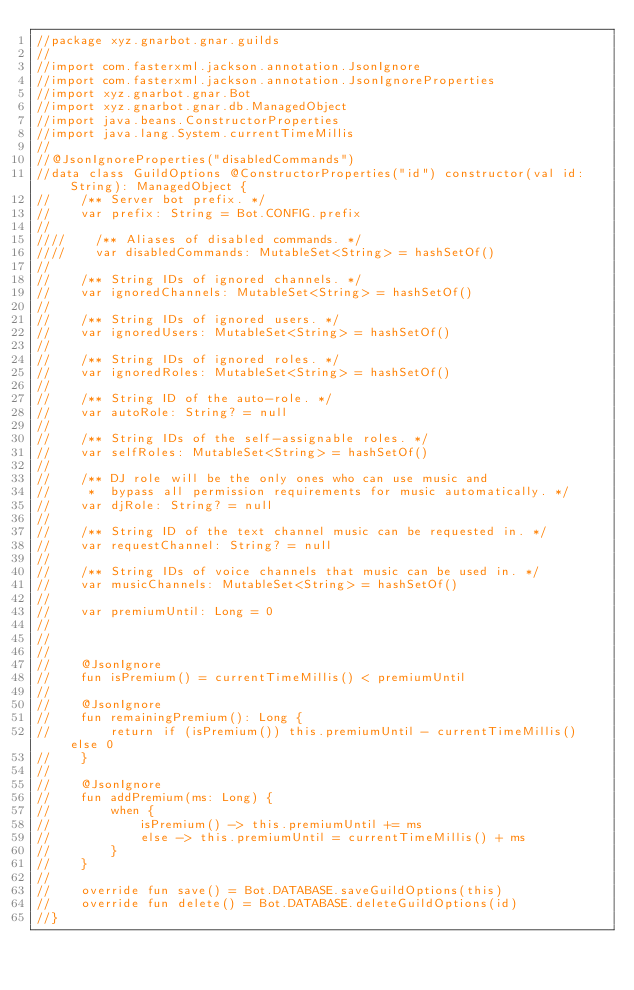Convert code to text. <code><loc_0><loc_0><loc_500><loc_500><_Kotlin_>//package xyz.gnarbot.gnar.guilds
//
//import com.fasterxml.jackson.annotation.JsonIgnore
//import com.fasterxml.jackson.annotation.JsonIgnoreProperties
//import xyz.gnarbot.gnar.Bot
//import xyz.gnarbot.gnar.db.ManagedObject
//import java.beans.ConstructorProperties
//import java.lang.System.currentTimeMillis
//
//@JsonIgnoreProperties("disabledCommands")
//data class GuildOptions @ConstructorProperties("id") constructor(val id: String): ManagedObject {
//    /** Server bot prefix. */
//    var prefix: String = Bot.CONFIG.prefix
//
////    /** Aliases of disabled commands. */
////    var disabledCommands: MutableSet<String> = hashSetOf()
//
//    /** String IDs of ignored channels. */
//    var ignoredChannels: MutableSet<String> = hashSetOf()
//
//    /** String IDs of ignored users. */
//    var ignoredUsers: MutableSet<String> = hashSetOf()
//
//    /** String IDs of ignored roles. */
//    var ignoredRoles: MutableSet<String> = hashSetOf()
//
//    /** String ID of the auto-role. */
//    var autoRole: String? = null
//
//    /** String IDs of the self-assignable roles. */
//    var selfRoles: MutableSet<String> = hashSetOf()
//
//    /** DJ role will be the only ones who can use music and
//     *  bypass all permission requirements for music automatically. */
//    var djRole: String? = null
//
//    /** String ID of the text channel music can be requested in. */
//    var requestChannel: String? = null
//
//    /** String IDs of voice channels that music can be used in. */
//    var musicChannels: MutableSet<String> = hashSetOf()
//
//    var premiumUntil: Long = 0
//
//
//
//    @JsonIgnore
//    fun isPremium() = currentTimeMillis() < premiumUntil
//
//    @JsonIgnore
//    fun remainingPremium(): Long {
//        return if (isPremium()) this.premiumUntil - currentTimeMillis() else 0
//    }
//
//    @JsonIgnore
//    fun addPremium(ms: Long) {
//        when {
//            isPremium() -> this.premiumUntil += ms
//            else -> this.premiumUntil = currentTimeMillis() + ms
//        }
//    }
//
//    override fun save() = Bot.DATABASE.saveGuildOptions(this)
//    override fun delete() = Bot.DATABASE.deleteGuildOptions(id)
//}</code> 